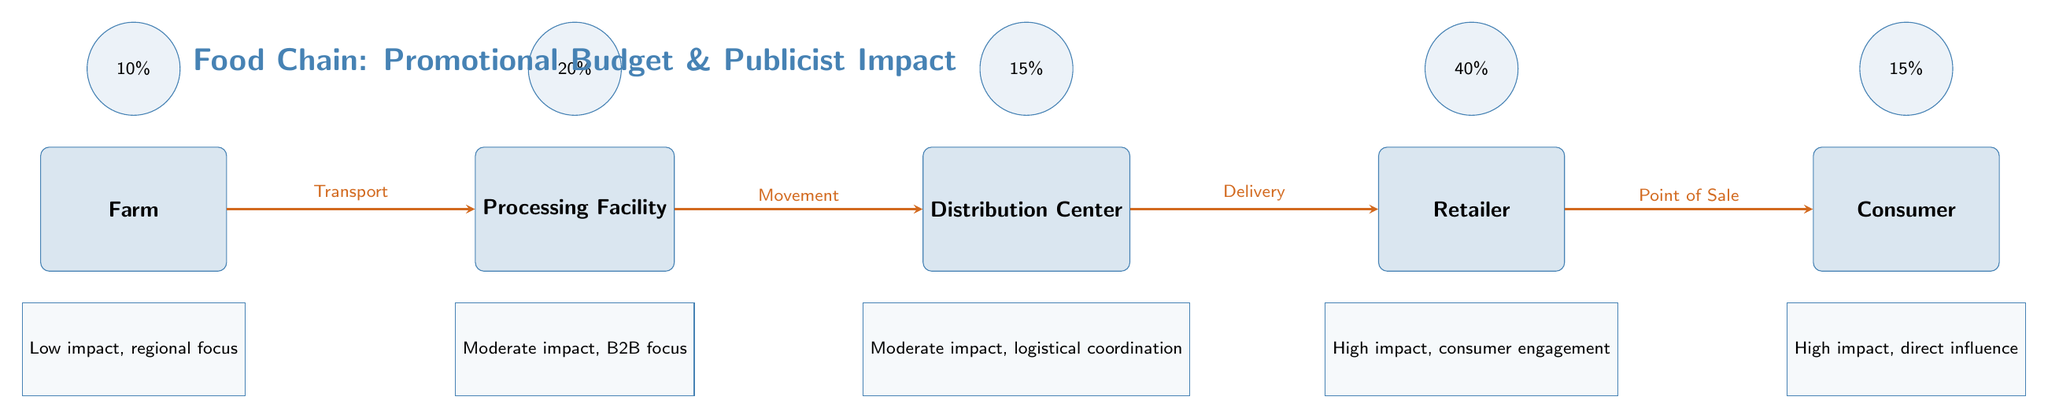What is the budget allocation for the Retailer? The diagram shows a specific budget allocation value above the node labeled 'Retailer'. The budget allocation for the Retailer is 40%.
Answer: 40% How many nodes are in the diagram? The diagram has five primary nodes: Farm, Processing Facility, Distribution Center, Retailer, and Consumer, which totals up to five nodes.
Answer: 5 What is the impact potential at the Processing Facility? Under the Processing Facility, the diagram indicates "Moderate impact, B2B focus," which describes the potential impact that publicists can have at this stage.
Answer: Moderate impact, B2B focus Which stage has the highest budget allocation? By visually comparing the budget values indicated above each node, the Retailer with 40% has the highest allocation.
Answer: Retailer What does the arrow from the Retailer to the Consumer signify? The diagram has an arrow pointing from the Retailer node to the Consumer node, labeled "Point of Sale," indicating the promotional flow from the Retailer to the Consumer.
Answer: Point of Sale What is the combined percentage of the budget allocated to Farm and Consumer? Adding the budget allocations for Farm (10%) and Consumer (15%) results in a total budget allocation of 25%.
Answer: 25% What stage has a high impact focused on consumer engagement? The Retailer node is labeled as having "High impact, consumer engagement," which specifies its significance in engaging with consumers effectively.
Answer: Retailer Which stage has the lowest budget allocation? The diagram shows the budget allocation for the Farm is 10%, which is the lowest amount among all the stages.
Answer: Farm 